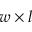<formula> <loc_0><loc_0><loc_500><loc_500>w \times l</formula> 